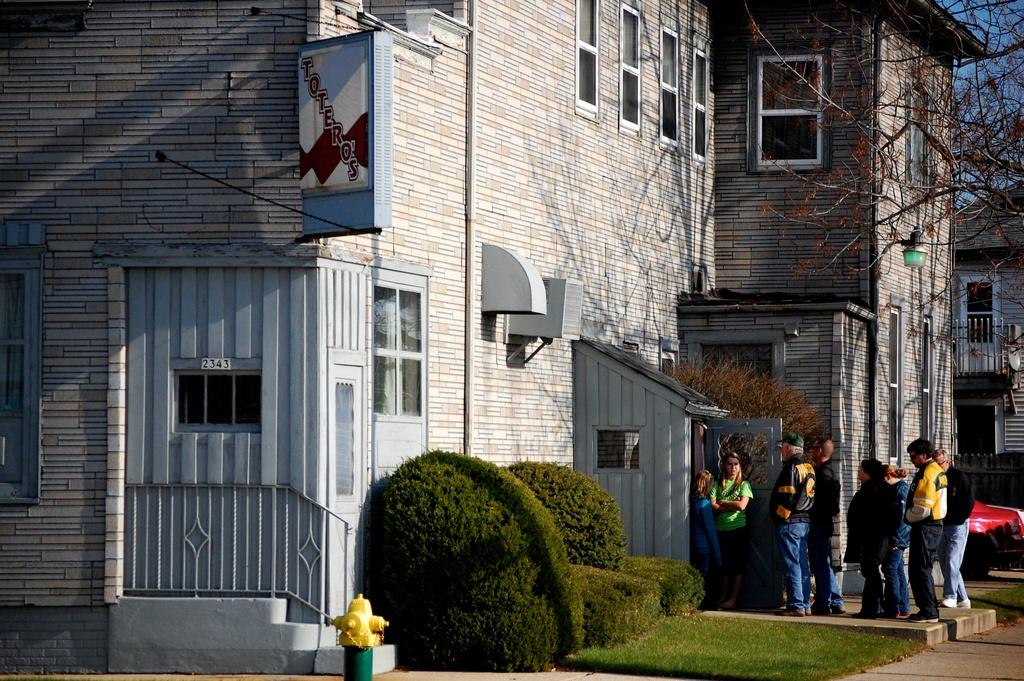What type of structures can be seen in the image? There are buildings in the image. What other elements are present in the image besides buildings? There are plants and people in the image. What type of coastline can be seen in the image? There is no coastline present in the image; it features buildings, plants, and people. 